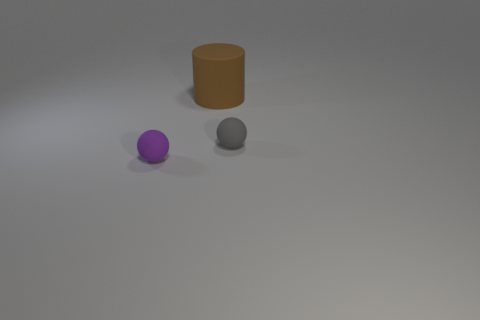Add 3 tiny red cubes. How many objects exist? 6 Subtract 1 spheres. How many spheres are left? 1 Subtract all cylinders. How many objects are left? 2 Subtract all brown balls. Subtract all blue cubes. How many balls are left? 2 Subtract all green cubes. How many purple balls are left? 1 Subtract 1 purple spheres. How many objects are left? 2 Subtract all small purple matte cylinders. Subtract all rubber cylinders. How many objects are left? 2 Add 3 tiny gray rubber spheres. How many tiny gray rubber spheres are left? 4 Add 2 tiny rubber objects. How many tiny rubber objects exist? 4 